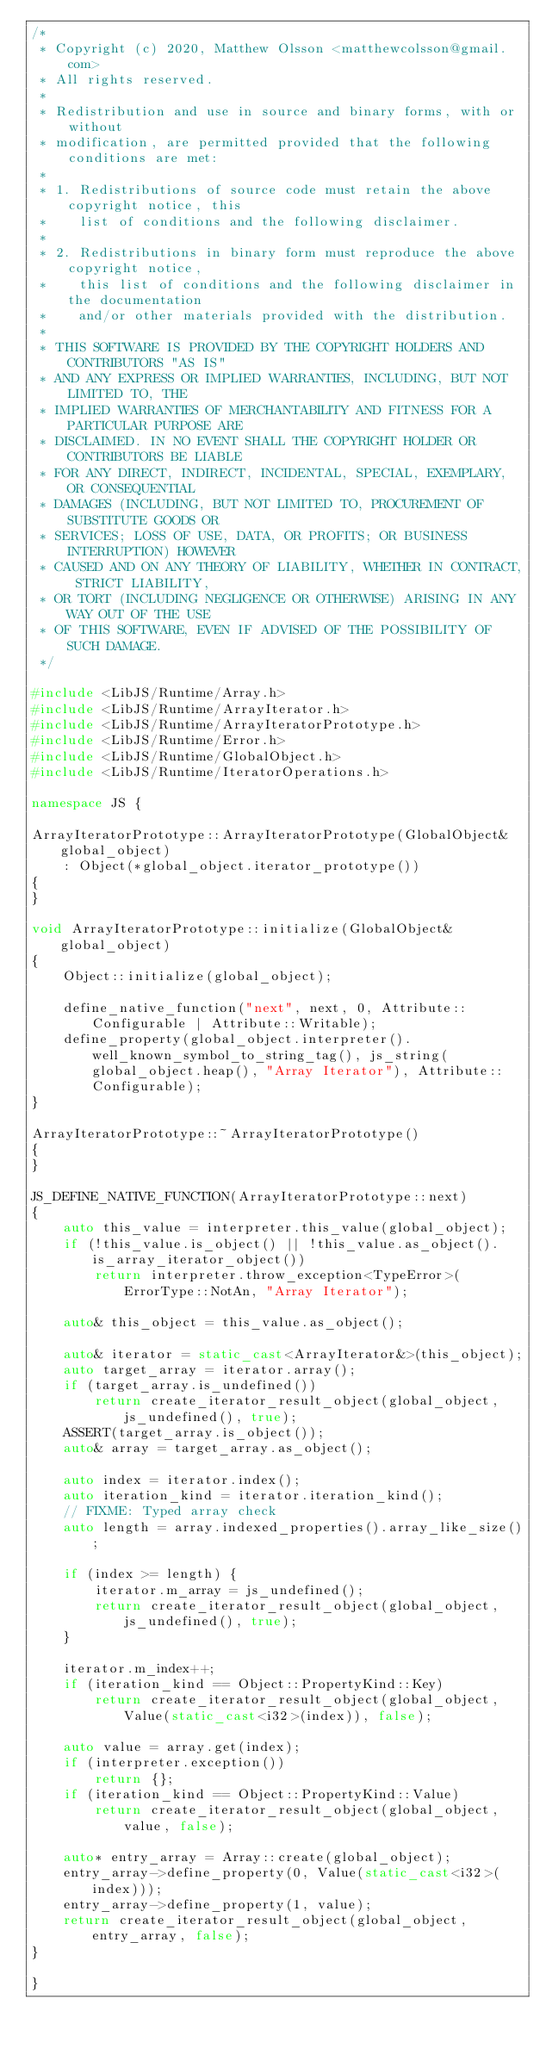<code> <loc_0><loc_0><loc_500><loc_500><_C++_>/*
 * Copyright (c) 2020, Matthew Olsson <matthewcolsson@gmail.com>
 * All rights reserved.
 *
 * Redistribution and use in source and binary forms, with or without
 * modification, are permitted provided that the following conditions are met:
 *
 * 1. Redistributions of source code must retain the above copyright notice, this
 *    list of conditions and the following disclaimer.
 *
 * 2. Redistributions in binary form must reproduce the above copyright notice,
 *    this list of conditions and the following disclaimer in the documentation
 *    and/or other materials provided with the distribution.
 *
 * THIS SOFTWARE IS PROVIDED BY THE COPYRIGHT HOLDERS AND CONTRIBUTORS "AS IS"
 * AND ANY EXPRESS OR IMPLIED WARRANTIES, INCLUDING, BUT NOT LIMITED TO, THE
 * IMPLIED WARRANTIES OF MERCHANTABILITY AND FITNESS FOR A PARTICULAR PURPOSE ARE
 * DISCLAIMED. IN NO EVENT SHALL THE COPYRIGHT HOLDER OR CONTRIBUTORS BE LIABLE
 * FOR ANY DIRECT, INDIRECT, INCIDENTAL, SPECIAL, EXEMPLARY, OR CONSEQUENTIAL
 * DAMAGES (INCLUDING, BUT NOT LIMITED TO, PROCUREMENT OF SUBSTITUTE GOODS OR
 * SERVICES; LOSS OF USE, DATA, OR PROFITS; OR BUSINESS INTERRUPTION) HOWEVER
 * CAUSED AND ON ANY THEORY OF LIABILITY, WHETHER IN CONTRACT, STRICT LIABILITY,
 * OR TORT (INCLUDING NEGLIGENCE OR OTHERWISE) ARISING IN ANY WAY OUT OF THE USE
 * OF THIS SOFTWARE, EVEN IF ADVISED OF THE POSSIBILITY OF SUCH DAMAGE.
 */

#include <LibJS/Runtime/Array.h>
#include <LibJS/Runtime/ArrayIterator.h>
#include <LibJS/Runtime/ArrayIteratorPrototype.h>
#include <LibJS/Runtime/Error.h>
#include <LibJS/Runtime/GlobalObject.h>
#include <LibJS/Runtime/IteratorOperations.h>

namespace JS {

ArrayIteratorPrototype::ArrayIteratorPrototype(GlobalObject& global_object)
    : Object(*global_object.iterator_prototype())
{
}

void ArrayIteratorPrototype::initialize(GlobalObject& global_object)
{
    Object::initialize(global_object);

    define_native_function("next", next, 0, Attribute::Configurable | Attribute::Writable);
    define_property(global_object.interpreter().well_known_symbol_to_string_tag(), js_string(global_object.heap(), "Array Iterator"), Attribute::Configurable);
}

ArrayIteratorPrototype::~ArrayIteratorPrototype()
{
}

JS_DEFINE_NATIVE_FUNCTION(ArrayIteratorPrototype::next)
{
    auto this_value = interpreter.this_value(global_object);
    if (!this_value.is_object() || !this_value.as_object().is_array_iterator_object())
        return interpreter.throw_exception<TypeError>(ErrorType::NotAn, "Array Iterator");

    auto& this_object = this_value.as_object();

    auto& iterator = static_cast<ArrayIterator&>(this_object);
    auto target_array = iterator.array();
    if (target_array.is_undefined())
        return create_iterator_result_object(global_object, js_undefined(), true);
    ASSERT(target_array.is_object());
    auto& array = target_array.as_object();

    auto index = iterator.index();
    auto iteration_kind = iterator.iteration_kind();
    // FIXME: Typed array check
    auto length = array.indexed_properties().array_like_size();

    if (index >= length) {
        iterator.m_array = js_undefined();
        return create_iterator_result_object(global_object, js_undefined(), true);
    }

    iterator.m_index++;
    if (iteration_kind == Object::PropertyKind::Key)
        return create_iterator_result_object(global_object, Value(static_cast<i32>(index)), false);

    auto value = array.get(index);
    if (interpreter.exception())
        return {};
    if (iteration_kind == Object::PropertyKind::Value)
        return create_iterator_result_object(global_object, value, false);

    auto* entry_array = Array::create(global_object);
    entry_array->define_property(0, Value(static_cast<i32>(index)));
    entry_array->define_property(1, value);
    return create_iterator_result_object(global_object, entry_array, false);
}

}
</code> 